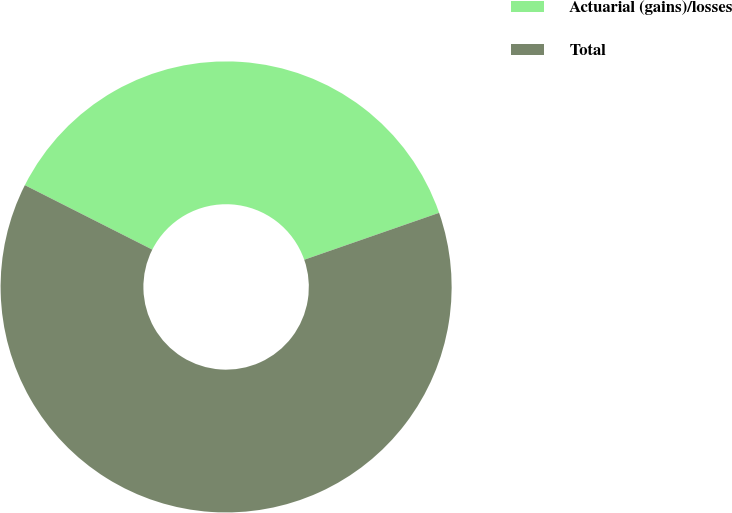Convert chart to OTSL. <chart><loc_0><loc_0><loc_500><loc_500><pie_chart><fcel>Actuarial (gains)/losses<fcel>Total<nl><fcel>37.22%<fcel>62.78%<nl></chart> 